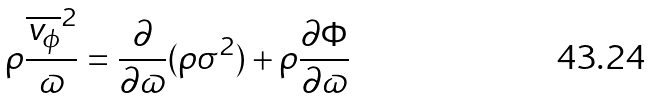<formula> <loc_0><loc_0><loc_500><loc_500>\rho \frac { \overline { v _ { \phi } } ^ { 2 } } { \varpi } = \frac { \partial } { \partial \varpi } ( \rho \sigma ^ { 2 } ) + \rho \frac { \partial \Phi } { \partial \varpi }</formula> 